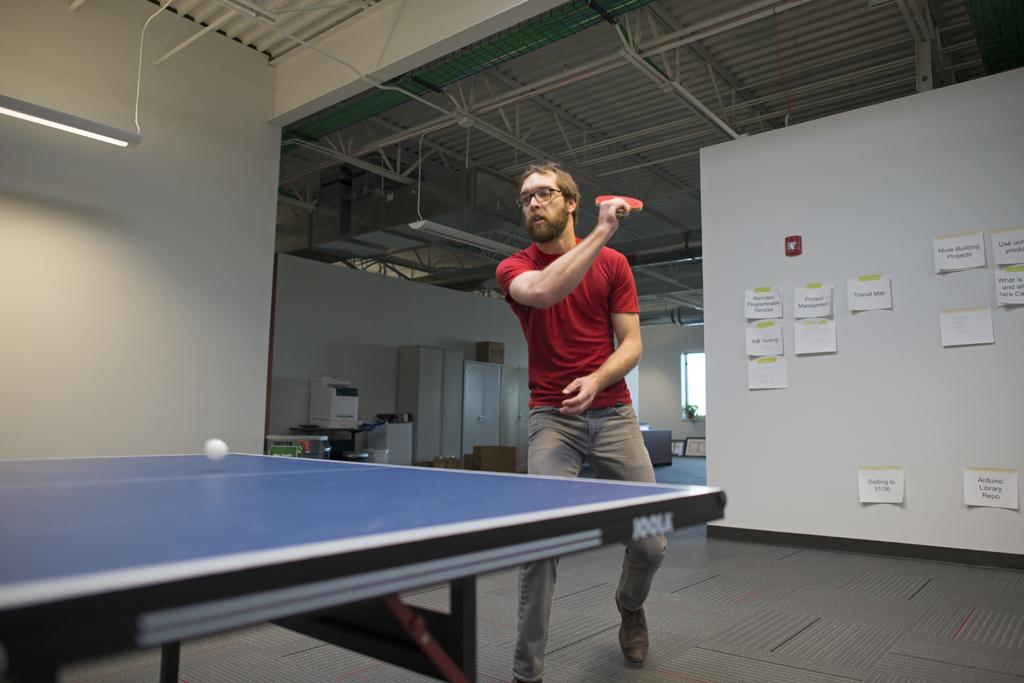What is the main subject of the image? There is a man in the image. What activity is the man engaged in? The man is playing table tennis. What type of prose is the man reading while playing table tennis? There is no indication in the image that the man is reading any prose, as he is focused on playing table tennis. 